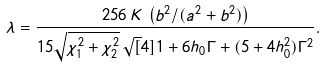<formula> <loc_0><loc_0><loc_500><loc_500>\lambda = \frac { 2 5 6 \, K \, \left ( b ^ { 2 } / ( a ^ { 2 } + b ^ { 2 } ) \right ) } { 1 5 \sqrt { \chi _ { 1 } ^ { 2 } + \chi _ { 2 } ^ { 2 } } \, \sqrt { [ } 4 ] { 1 + 6 h _ { 0 } \Gamma + ( 5 + 4 h _ { 0 } ^ { 2 } ) \Gamma ^ { 2 } } } .</formula> 